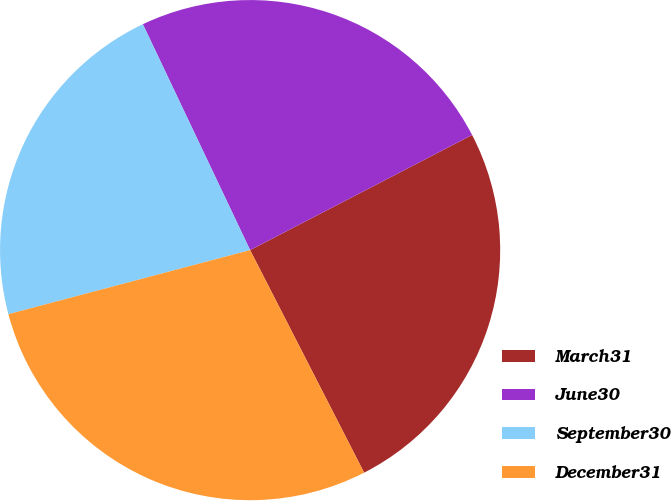<chart> <loc_0><loc_0><loc_500><loc_500><pie_chart><fcel>March31<fcel>June30<fcel>September30<fcel>December31<nl><fcel>25.08%<fcel>24.44%<fcel>22.07%<fcel>28.41%<nl></chart> 